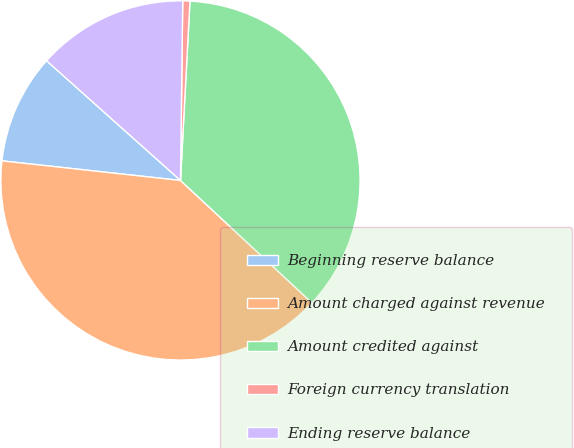Convert chart. <chart><loc_0><loc_0><loc_500><loc_500><pie_chart><fcel>Beginning reserve balance<fcel>Amount charged against revenue<fcel>Amount credited against<fcel>Foreign currency translation<fcel>Ending reserve balance<nl><fcel>9.87%<fcel>39.81%<fcel>36.09%<fcel>0.64%<fcel>13.59%<nl></chart> 